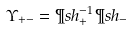<formula> <loc_0><loc_0><loc_500><loc_500>\Upsilon _ { + - } = \P s h _ { + } ^ { - 1 } \P s h _ { - }</formula> 